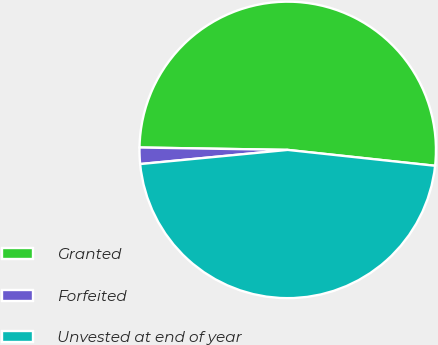Convert chart. <chart><loc_0><loc_0><loc_500><loc_500><pie_chart><fcel>Granted<fcel>Forfeited<fcel>Unvested at end of year<nl><fcel>51.45%<fcel>1.78%<fcel>46.77%<nl></chart> 